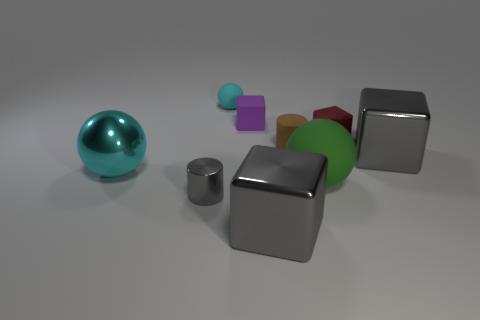Subtract 1 cubes. How many cubes are left? 3 Subtract all red cubes. How many cubes are left? 3 Subtract all cyan cubes. Subtract all yellow cylinders. How many cubes are left? 4 Add 1 small cyan balls. How many objects exist? 10 Subtract all cylinders. How many objects are left? 7 Add 4 brown matte things. How many brown matte things are left? 5 Add 6 big purple objects. How many big purple objects exist? 6 Subtract 0 yellow blocks. How many objects are left? 9 Subtract all small brown matte things. Subtract all cyan objects. How many objects are left? 6 